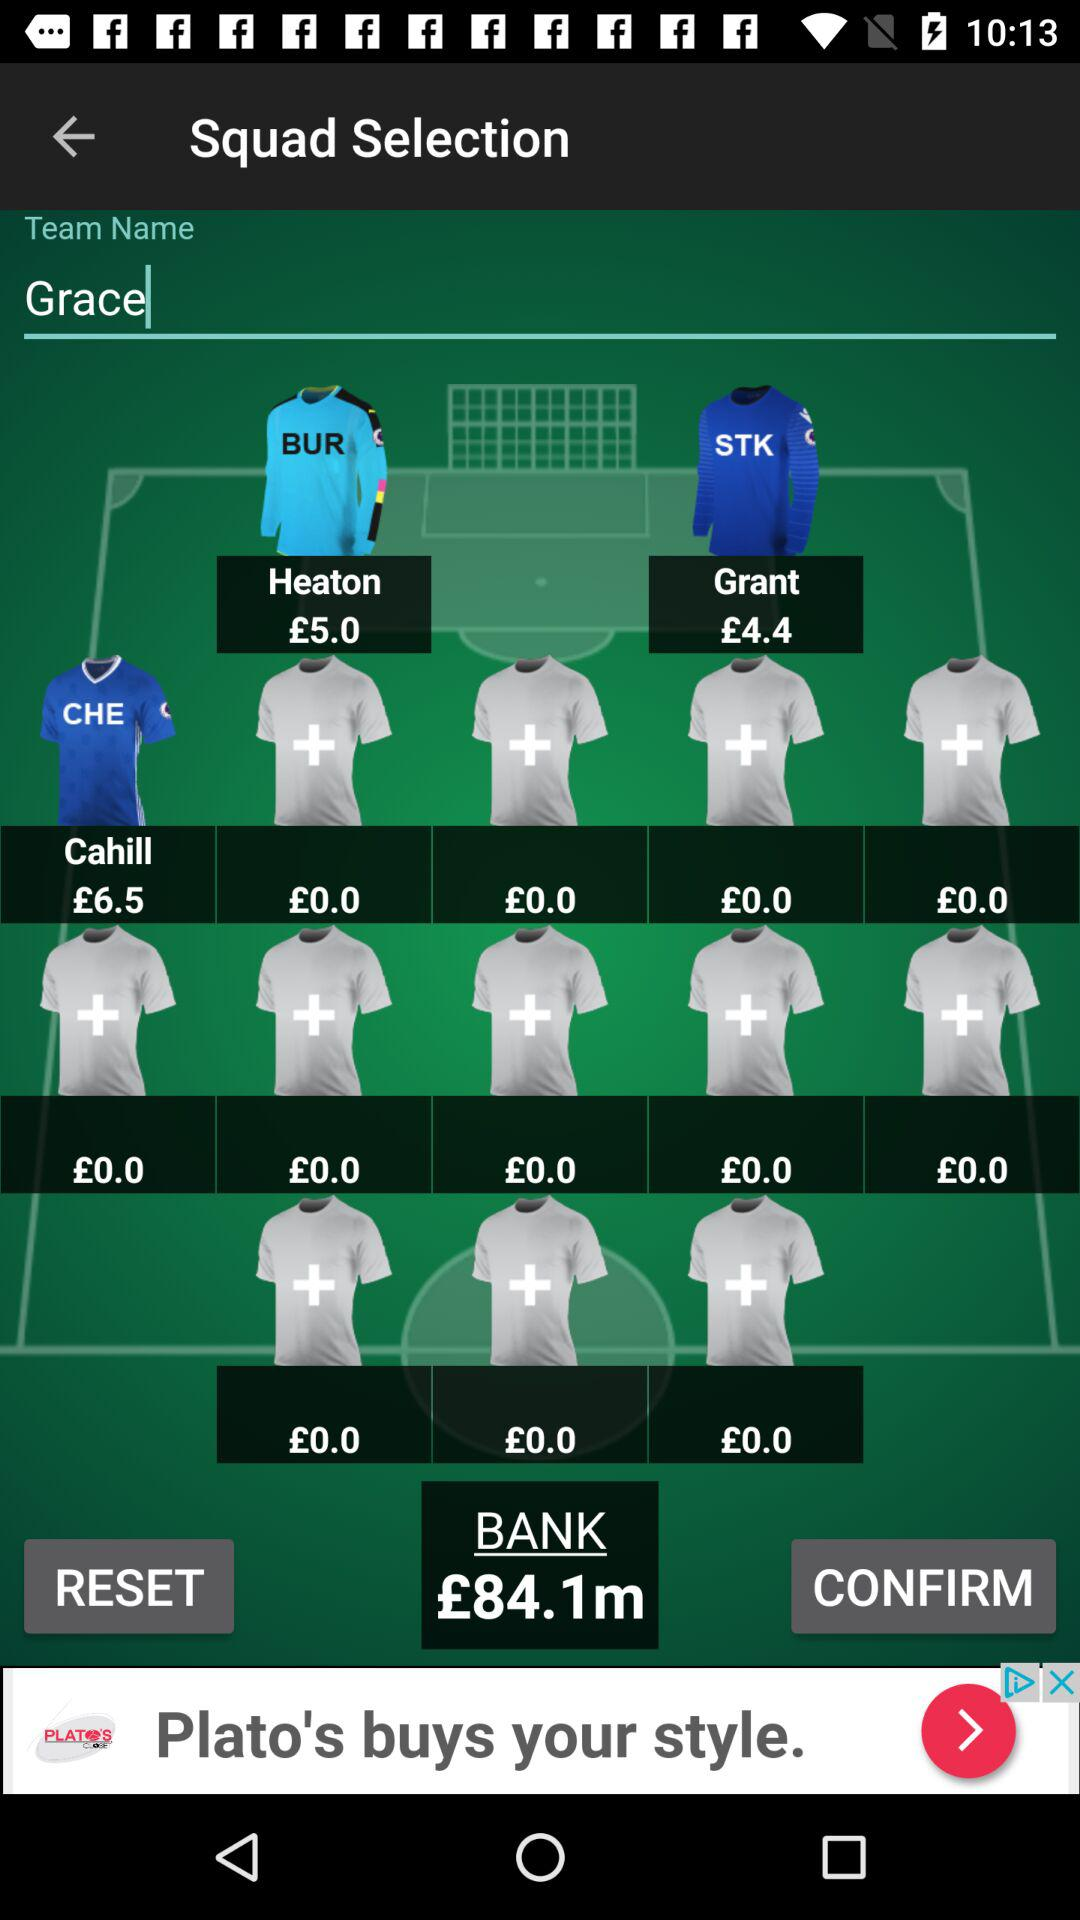What's the team name? The team name is "Grace". 